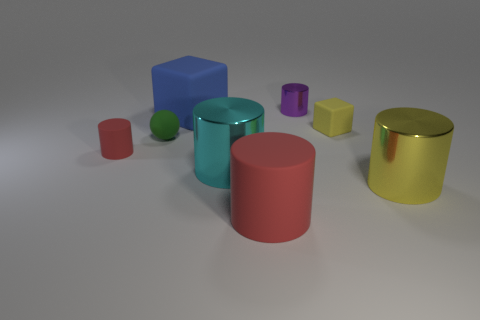Are there any small red cylinders that have the same material as the big red object?
Offer a very short reply. Yes. There is a metal cylinder behind the small red object; are there any big yellow metallic cylinders that are in front of it?
Give a very brief answer. Yes. Is the size of the red object in front of the yellow metal cylinder the same as the cyan thing?
Your answer should be compact. Yes. How big is the green ball?
Ensure brevity in your answer.  Small. Is there a rubber cylinder of the same color as the big cube?
Give a very brief answer. No. How many big objects are purple metallic objects or gray metallic objects?
Keep it short and to the point. 0. There is a metallic cylinder that is on the left side of the small yellow rubber object and in front of the small metallic cylinder; what is its size?
Give a very brief answer. Large. What number of blue objects are to the left of the small purple metallic thing?
Your answer should be compact. 1. What shape is the thing that is both on the left side of the large red rubber thing and behind the small green matte thing?
Keep it short and to the point. Cube. There is a large cylinder that is the same color as the tiny block; what is its material?
Provide a short and direct response. Metal. 